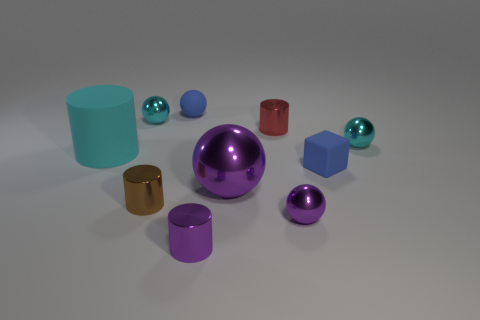Subtract all tiny blue balls. How many balls are left? 4 Subtract all blue spheres. How many spheres are left? 4 Subtract 1 cylinders. How many cylinders are left? 3 Subtract all yellow spheres. Subtract all red cubes. How many spheres are left? 5 Subtract all cylinders. How many objects are left? 6 Add 3 cyan rubber cylinders. How many cyan rubber cylinders are left? 4 Add 7 small matte spheres. How many small matte spheres exist? 8 Subtract 0 green spheres. How many objects are left? 10 Subtract all large blue blocks. Subtract all cyan shiny balls. How many objects are left? 8 